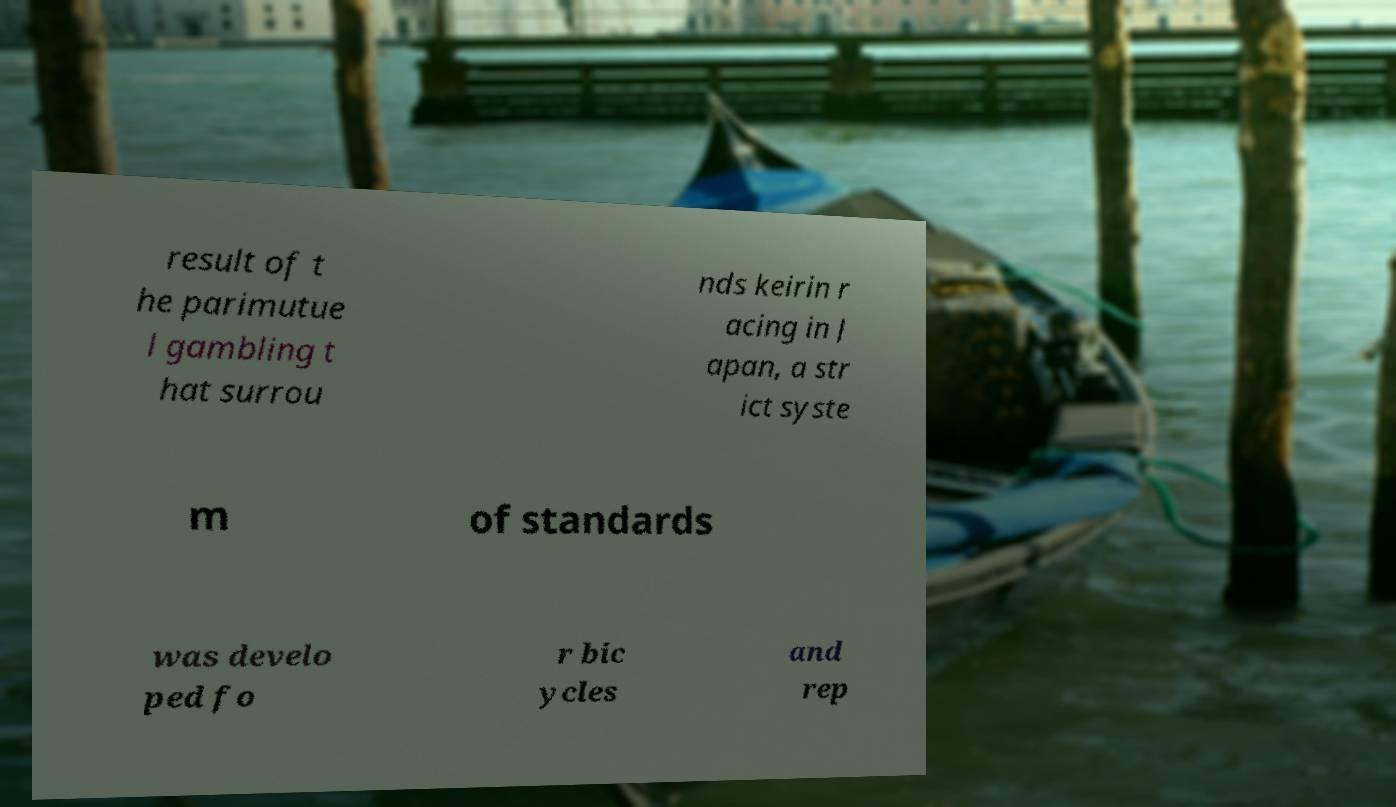There's text embedded in this image that I need extracted. Can you transcribe it verbatim? result of t he parimutue l gambling t hat surrou nds keirin r acing in J apan, a str ict syste m of standards was develo ped fo r bic ycles and rep 